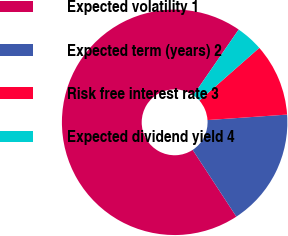Convert chart. <chart><loc_0><loc_0><loc_500><loc_500><pie_chart><fcel>Expected volatility 1<fcel>Expected term (years) 2<fcel>Risk free interest rate 3<fcel>Expected dividend yield 4<nl><fcel>68.84%<fcel>16.87%<fcel>10.39%<fcel>3.9%<nl></chart> 